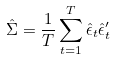Convert formula to latex. <formula><loc_0><loc_0><loc_500><loc_500>\hat { \Sigma } = \frac { 1 } { T } \sum _ { t = 1 } ^ { T } \hat { \epsilon } _ { t } \hat { \epsilon } _ { t } ^ { \prime }</formula> 